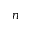<formula> <loc_0><loc_0><loc_500><loc_500>n</formula> 